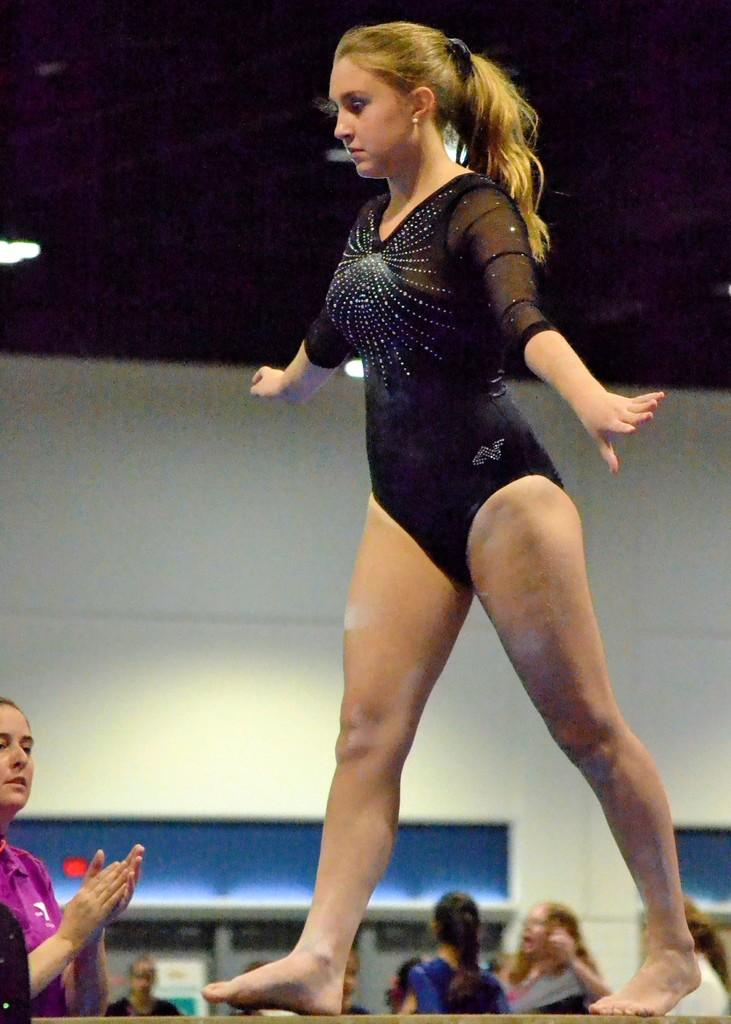What is the person in the image doing? There is a person walking in the image. What is the person wearing? The person is wearing a black dress. What can be seen in the background of the image? There are people and a wall visible in the background of the image. What else can be seen in the background of the image? There are lights visible in the background of the image. What month is it in the image? The month cannot be determined from the image, as there is no information about the time of year. 